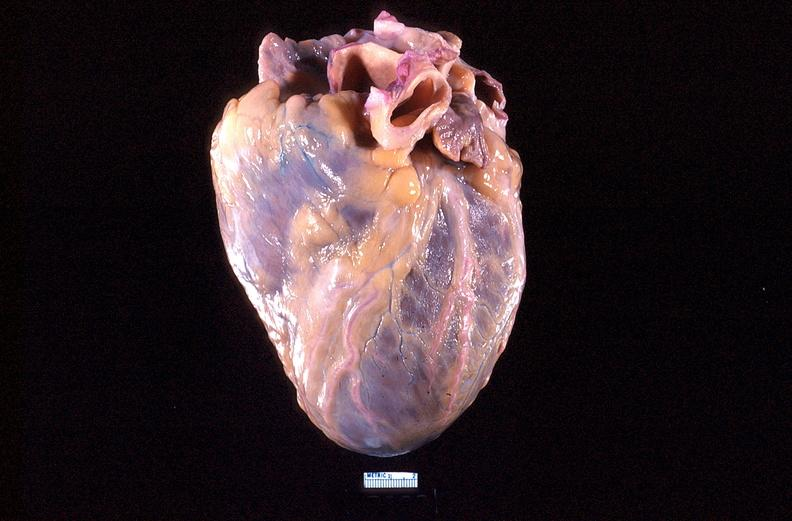what is present?
Answer the question using a single word or phrase. Cardiovascular 